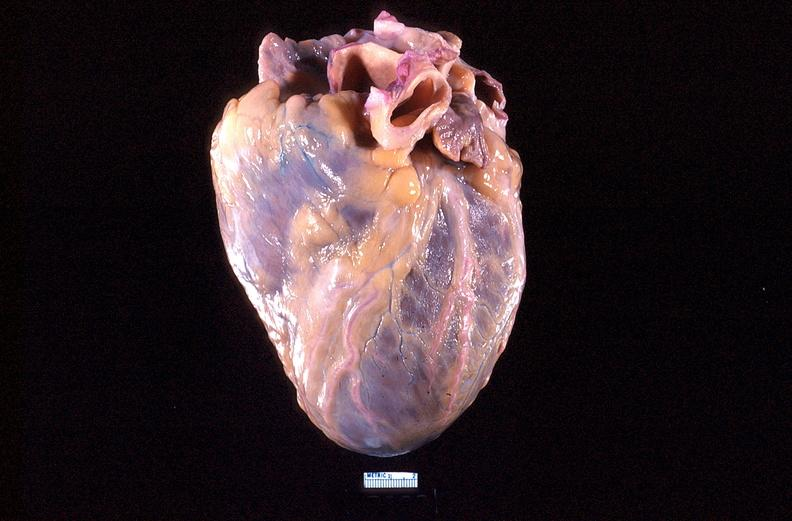what is present?
Answer the question using a single word or phrase. Cardiovascular 